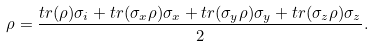<formula> <loc_0><loc_0><loc_500><loc_500>\rho = \frac { t r ( \rho ) \sigma _ { i } + t r ( \sigma _ { x } \rho ) \sigma _ { x } + t r ( \sigma _ { y } \rho ) \sigma _ { y } + t r ( \sigma _ { z } \rho ) \sigma _ { z } } { 2 } .</formula> 